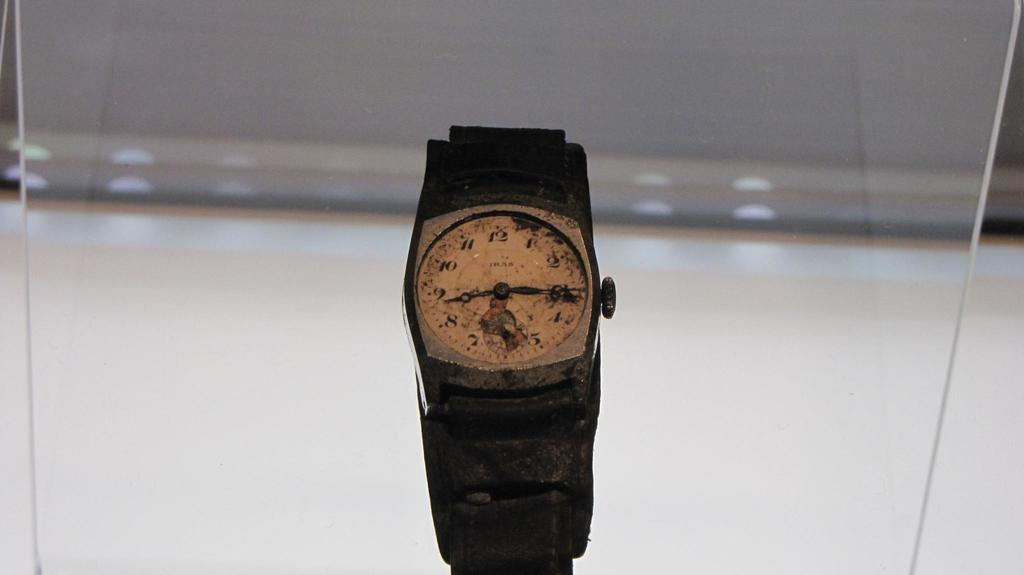<image>
Provide a brief description of the given image. A very old wristwatch, with the brand name IRAS, sits in a display case. 